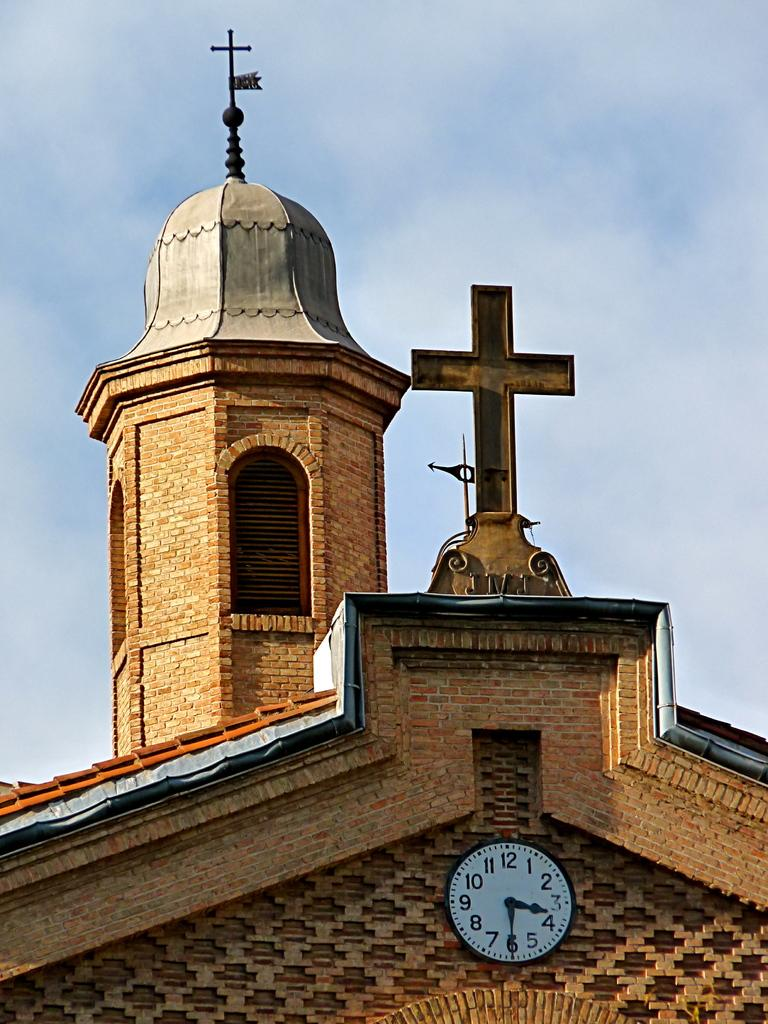<image>
Relay a brief, clear account of the picture shown. A church with a clock underneath it and the time set to three thirty. 